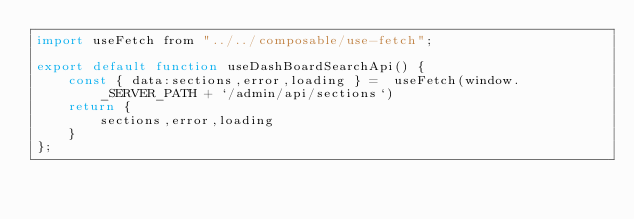Convert code to text. <code><loc_0><loc_0><loc_500><loc_500><_JavaScript_>import useFetch from "../../composable/use-fetch";

export default function useDashBoardSearchApi() {
    const { data:sections,error,loading } =  useFetch(window._SERVER_PATH + `/admin/api/sections`)
    return {
        sections,error,loading
    }
};</code> 